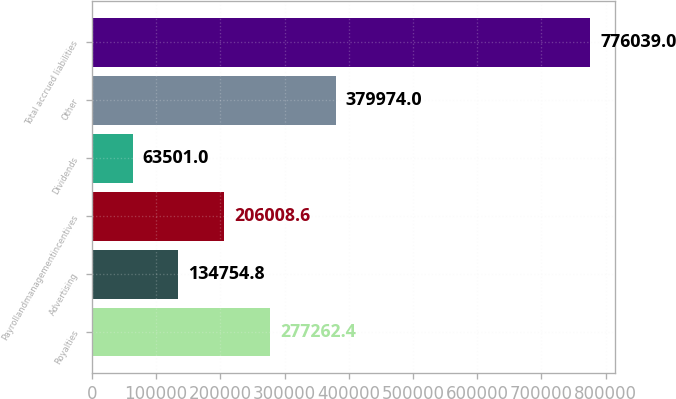Convert chart. <chart><loc_0><loc_0><loc_500><loc_500><bar_chart><fcel>Royalties<fcel>Advertising<fcel>Payrollandmanagementincentives<fcel>Dividends<fcel>Other<fcel>Total accrued liabilities<nl><fcel>277262<fcel>134755<fcel>206009<fcel>63501<fcel>379974<fcel>776039<nl></chart> 